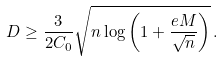Convert formula to latex. <formula><loc_0><loc_0><loc_500><loc_500>D \geq \frac { 3 } { 2 C _ { 0 } } \sqrt { n \log \left ( 1 + \frac { e M } { \sqrt { n } } \right ) } \, .</formula> 